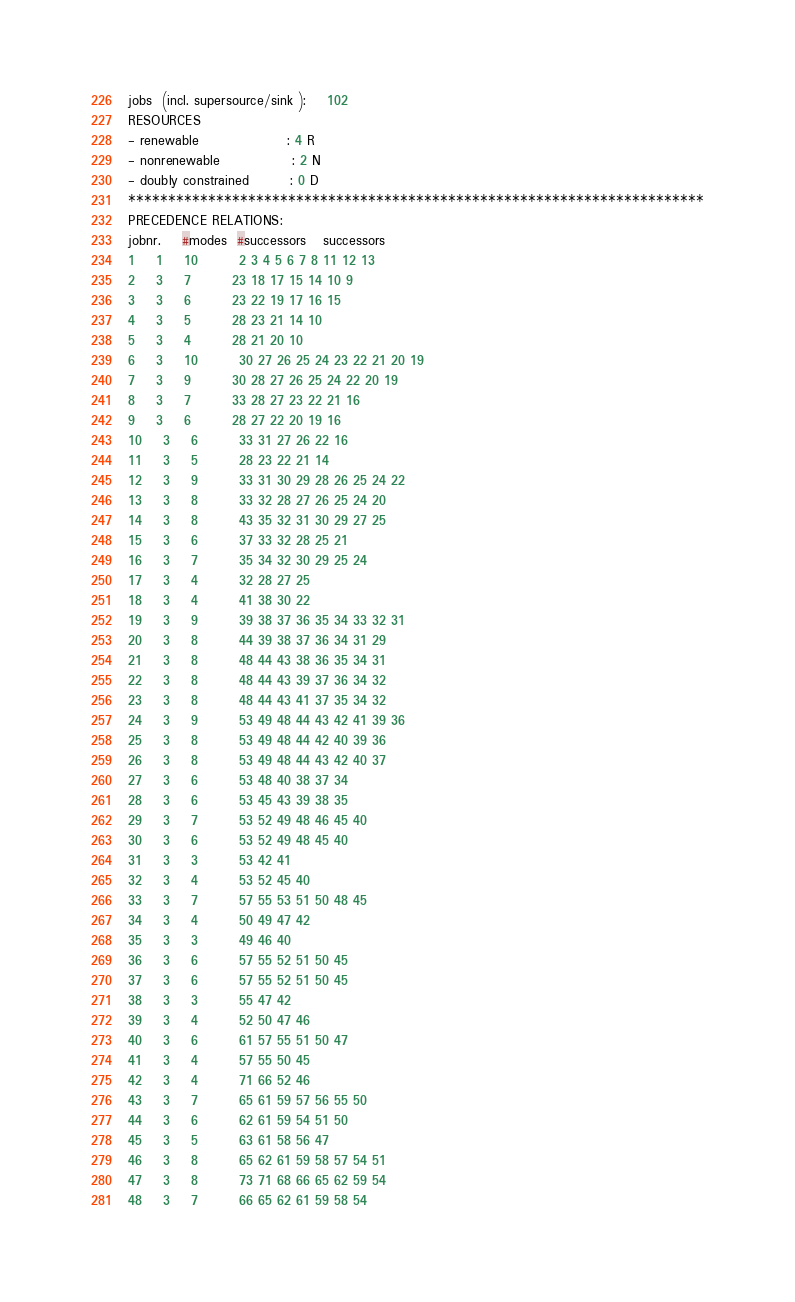<code> <loc_0><loc_0><loc_500><loc_500><_ObjectiveC_>jobs  (incl. supersource/sink ):	102
RESOURCES
- renewable                 : 4 R
- nonrenewable              : 2 N
- doubly constrained        : 0 D
************************************************************************
PRECEDENCE RELATIONS:
jobnr.    #modes  #successors   successors
1	1	10		2 3 4 5 6 7 8 11 12 13 
2	3	7		23 18 17 15 14 10 9 
3	3	6		23 22 19 17 16 15 
4	3	5		28 23 21 14 10 
5	3	4		28 21 20 10 
6	3	10		30 27 26 25 24 23 22 21 20 19 
7	3	9		30 28 27 26 25 24 22 20 19 
8	3	7		33 28 27 23 22 21 16 
9	3	6		28 27 22 20 19 16 
10	3	6		33 31 27 26 22 16 
11	3	5		28 23 22 21 14 
12	3	9		33 31 30 29 28 26 25 24 22 
13	3	8		33 32 28 27 26 25 24 20 
14	3	8		43 35 32 31 30 29 27 25 
15	3	6		37 33 32 28 25 21 
16	3	7		35 34 32 30 29 25 24 
17	3	4		32 28 27 25 
18	3	4		41 38 30 22 
19	3	9		39 38 37 36 35 34 33 32 31 
20	3	8		44 39 38 37 36 34 31 29 
21	3	8		48 44 43 38 36 35 34 31 
22	3	8		48 44 43 39 37 36 34 32 
23	3	8		48 44 43 41 37 35 34 32 
24	3	9		53 49 48 44 43 42 41 39 36 
25	3	8		53 49 48 44 42 40 39 36 
26	3	8		53 49 48 44 43 42 40 37 
27	3	6		53 48 40 38 37 34 
28	3	6		53 45 43 39 38 35 
29	3	7		53 52 49 48 46 45 40 
30	3	6		53 52 49 48 45 40 
31	3	3		53 42 41 
32	3	4		53 52 45 40 
33	3	7		57 55 53 51 50 48 45 
34	3	4		50 49 47 42 
35	3	3		49 46 40 
36	3	6		57 55 52 51 50 45 
37	3	6		57 55 52 51 50 45 
38	3	3		55 47 42 
39	3	4		52 50 47 46 
40	3	6		61 57 55 51 50 47 
41	3	4		57 55 50 45 
42	3	4		71 66 52 46 
43	3	7		65 61 59 57 56 55 50 
44	3	6		62 61 59 54 51 50 
45	3	5		63 61 58 56 47 
46	3	8		65 62 61 59 58 57 54 51 
47	3	8		73 71 68 66 65 62 59 54 
48	3	7		66 65 62 61 59 58 54 </code> 